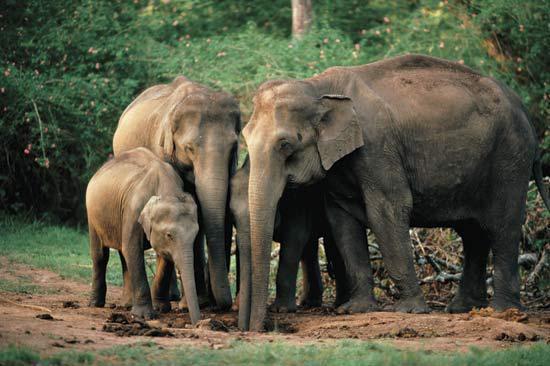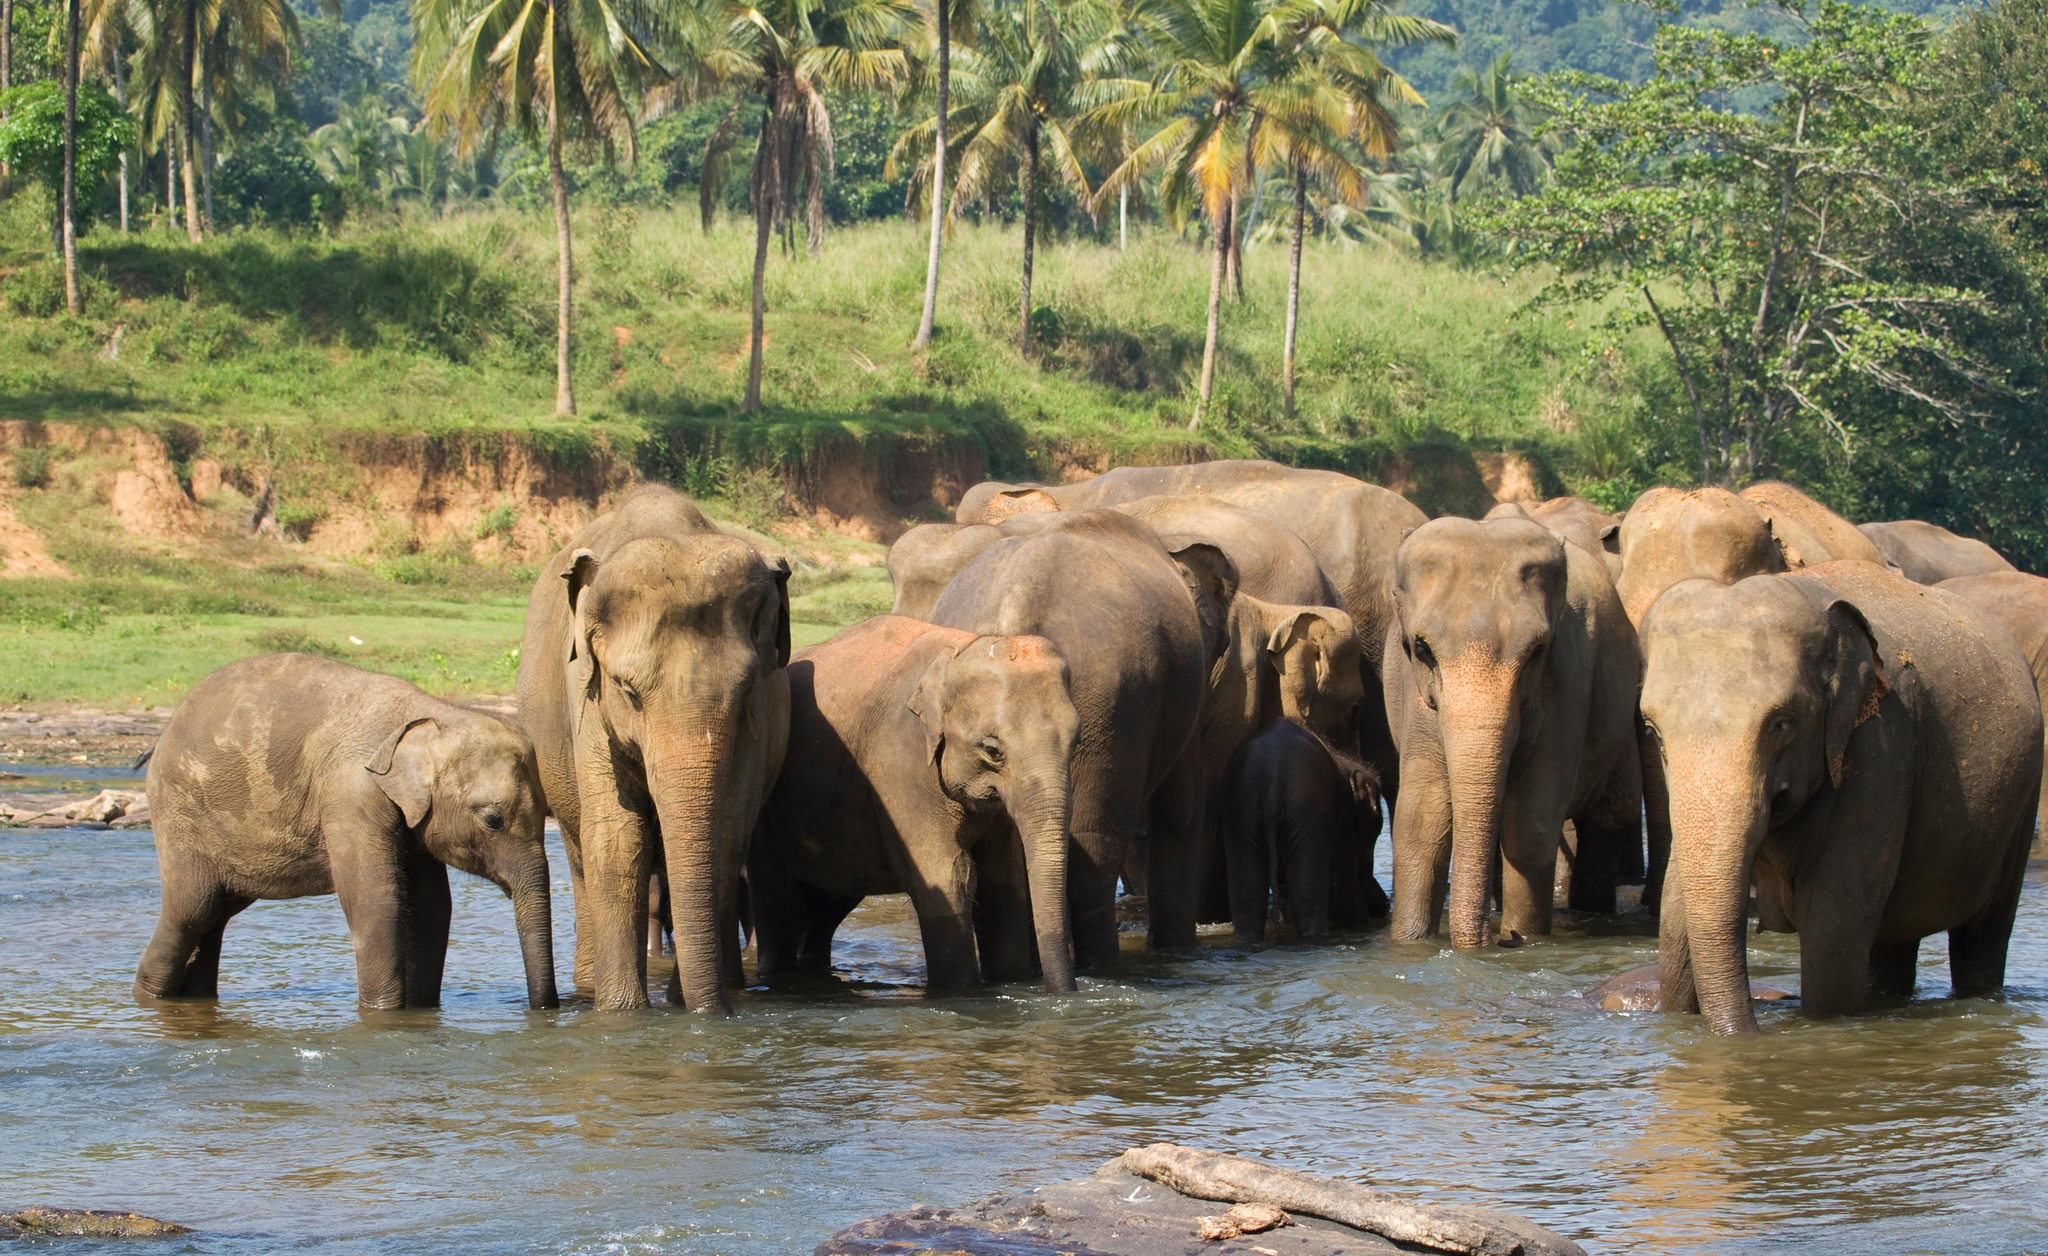The first image is the image on the left, the second image is the image on the right. Considering the images on both sides, is "Elephants are standing in or beside water in the right image." valid? Answer yes or no. Yes. The first image is the image on the left, the second image is the image on the right. Evaluate the accuracy of this statement regarding the images: "A water hole is present in a scene with multiple elephants of different ages.". Is it true? Answer yes or no. Yes. 